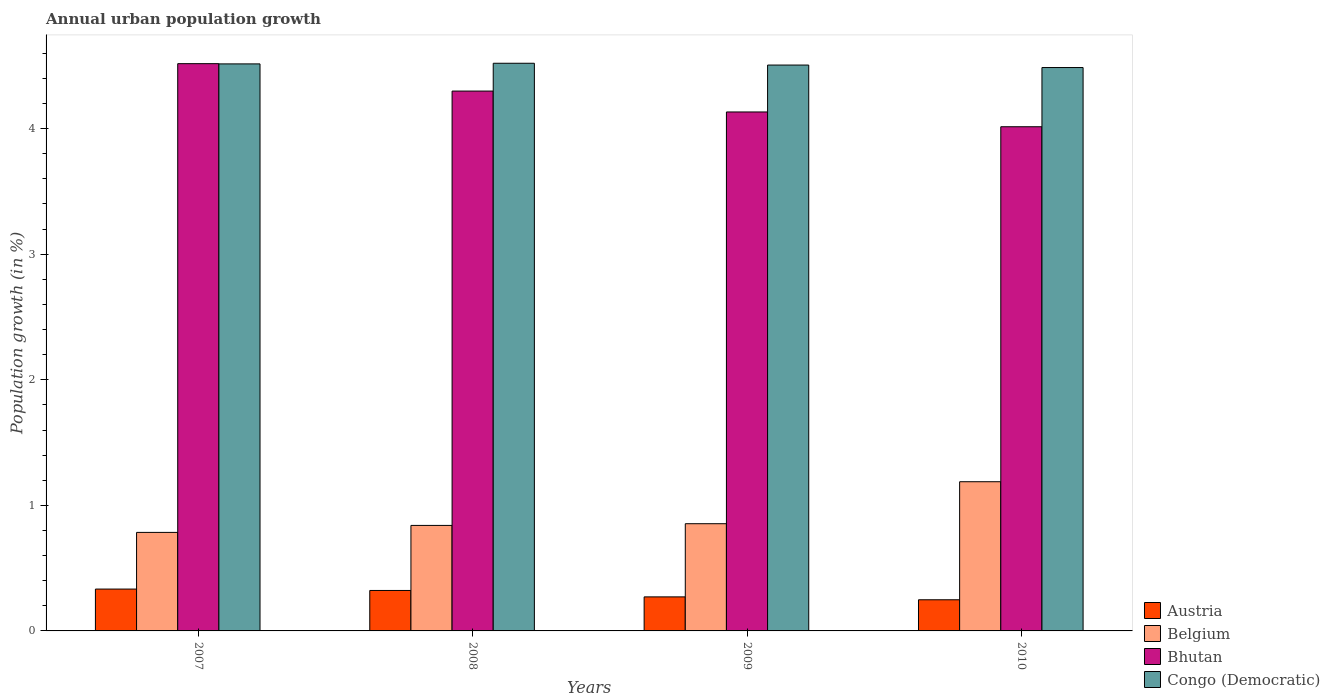How many different coloured bars are there?
Your answer should be compact. 4. How many groups of bars are there?
Keep it short and to the point. 4. What is the label of the 1st group of bars from the left?
Offer a terse response. 2007. What is the percentage of urban population growth in Bhutan in 2007?
Your answer should be compact. 4.52. Across all years, what is the maximum percentage of urban population growth in Belgium?
Ensure brevity in your answer.  1.19. Across all years, what is the minimum percentage of urban population growth in Bhutan?
Make the answer very short. 4.01. In which year was the percentage of urban population growth in Austria minimum?
Keep it short and to the point. 2010. What is the total percentage of urban population growth in Bhutan in the graph?
Ensure brevity in your answer.  16.96. What is the difference between the percentage of urban population growth in Congo (Democratic) in 2007 and that in 2008?
Your answer should be very brief. -0.01. What is the difference between the percentage of urban population growth in Austria in 2008 and the percentage of urban population growth in Belgium in 2007?
Your answer should be compact. -0.46. What is the average percentage of urban population growth in Austria per year?
Offer a very short reply. 0.29. In the year 2008, what is the difference between the percentage of urban population growth in Bhutan and percentage of urban population growth in Austria?
Make the answer very short. 3.98. What is the ratio of the percentage of urban population growth in Congo (Democratic) in 2009 to that in 2010?
Make the answer very short. 1. Is the percentage of urban population growth in Bhutan in 2008 less than that in 2010?
Provide a short and direct response. No. Is the difference between the percentage of urban population growth in Bhutan in 2008 and 2010 greater than the difference between the percentage of urban population growth in Austria in 2008 and 2010?
Provide a short and direct response. Yes. What is the difference between the highest and the second highest percentage of urban population growth in Austria?
Offer a very short reply. 0.01. What is the difference between the highest and the lowest percentage of urban population growth in Austria?
Your answer should be very brief. 0.09. Is it the case that in every year, the sum of the percentage of urban population growth in Bhutan and percentage of urban population growth in Austria is greater than the sum of percentage of urban population growth in Belgium and percentage of urban population growth in Congo (Democratic)?
Your answer should be compact. Yes. What does the 2nd bar from the right in 2009 represents?
Provide a short and direct response. Bhutan. How many bars are there?
Your answer should be very brief. 16. How many years are there in the graph?
Provide a short and direct response. 4. What is the difference between two consecutive major ticks on the Y-axis?
Provide a succinct answer. 1. Where does the legend appear in the graph?
Your answer should be very brief. Bottom right. How are the legend labels stacked?
Keep it short and to the point. Vertical. What is the title of the graph?
Provide a short and direct response. Annual urban population growth. Does "Eritrea" appear as one of the legend labels in the graph?
Provide a short and direct response. No. What is the label or title of the Y-axis?
Offer a terse response. Population growth (in %). What is the Population growth (in %) in Austria in 2007?
Offer a very short reply. 0.33. What is the Population growth (in %) in Belgium in 2007?
Offer a terse response. 0.78. What is the Population growth (in %) in Bhutan in 2007?
Make the answer very short. 4.52. What is the Population growth (in %) of Congo (Democratic) in 2007?
Your answer should be compact. 4.52. What is the Population growth (in %) of Austria in 2008?
Provide a short and direct response. 0.32. What is the Population growth (in %) in Belgium in 2008?
Your response must be concise. 0.84. What is the Population growth (in %) in Bhutan in 2008?
Offer a terse response. 4.3. What is the Population growth (in %) in Congo (Democratic) in 2008?
Offer a very short reply. 4.52. What is the Population growth (in %) in Austria in 2009?
Keep it short and to the point. 0.27. What is the Population growth (in %) in Belgium in 2009?
Give a very brief answer. 0.85. What is the Population growth (in %) of Bhutan in 2009?
Provide a succinct answer. 4.13. What is the Population growth (in %) of Congo (Democratic) in 2009?
Give a very brief answer. 4.51. What is the Population growth (in %) of Austria in 2010?
Provide a succinct answer. 0.25. What is the Population growth (in %) in Belgium in 2010?
Ensure brevity in your answer.  1.19. What is the Population growth (in %) in Bhutan in 2010?
Your response must be concise. 4.01. What is the Population growth (in %) in Congo (Democratic) in 2010?
Offer a very short reply. 4.49. Across all years, what is the maximum Population growth (in %) in Austria?
Ensure brevity in your answer.  0.33. Across all years, what is the maximum Population growth (in %) in Belgium?
Provide a short and direct response. 1.19. Across all years, what is the maximum Population growth (in %) in Bhutan?
Give a very brief answer. 4.52. Across all years, what is the maximum Population growth (in %) of Congo (Democratic)?
Provide a short and direct response. 4.52. Across all years, what is the minimum Population growth (in %) of Austria?
Keep it short and to the point. 0.25. Across all years, what is the minimum Population growth (in %) of Belgium?
Provide a short and direct response. 0.78. Across all years, what is the minimum Population growth (in %) in Bhutan?
Offer a very short reply. 4.01. Across all years, what is the minimum Population growth (in %) of Congo (Democratic)?
Provide a short and direct response. 4.49. What is the total Population growth (in %) of Austria in the graph?
Offer a very short reply. 1.17. What is the total Population growth (in %) of Belgium in the graph?
Keep it short and to the point. 3.67. What is the total Population growth (in %) of Bhutan in the graph?
Offer a very short reply. 16.96. What is the total Population growth (in %) of Congo (Democratic) in the graph?
Provide a short and direct response. 18.03. What is the difference between the Population growth (in %) of Austria in 2007 and that in 2008?
Provide a succinct answer. 0.01. What is the difference between the Population growth (in %) in Belgium in 2007 and that in 2008?
Offer a very short reply. -0.06. What is the difference between the Population growth (in %) in Bhutan in 2007 and that in 2008?
Give a very brief answer. 0.22. What is the difference between the Population growth (in %) of Congo (Democratic) in 2007 and that in 2008?
Ensure brevity in your answer.  -0.01. What is the difference between the Population growth (in %) of Austria in 2007 and that in 2009?
Keep it short and to the point. 0.06. What is the difference between the Population growth (in %) in Belgium in 2007 and that in 2009?
Offer a terse response. -0.07. What is the difference between the Population growth (in %) in Bhutan in 2007 and that in 2009?
Offer a terse response. 0.38. What is the difference between the Population growth (in %) in Congo (Democratic) in 2007 and that in 2009?
Make the answer very short. 0.01. What is the difference between the Population growth (in %) of Austria in 2007 and that in 2010?
Ensure brevity in your answer.  0.09. What is the difference between the Population growth (in %) in Belgium in 2007 and that in 2010?
Your answer should be compact. -0.4. What is the difference between the Population growth (in %) of Bhutan in 2007 and that in 2010?
Your answer should be very brief. 0.5. What is the difference between the Population growth (in %) in Congo (Democratic) in 2007 and that in 2010?
Keep it short and to the point. 0.03. What is the difference between the Population growth (in %) of Austria in 2008 and that in 2009?
Make the answer very short. 0.05. What is the difference between the Population growth (in %) in Belgium in 2008 and that in 2009?
Your response must be concise. -0.01. What is the difference between the Population growth (in %) in Bhutan in 2008 and that in 2009?
Your answer should be very brief. 0.17. What is the difference between the Population growth (in %) in Congo (Democratic) in 2008 and that in 2009?
Ensure brevity in your answer.  0.01. What is the difference between the Population growth (in %) of Austria in 2008 and that in 2010?
Make the answer very short. 0.07. What is the difference between the Population growth (in %) in Belgium in 2008 and that in 2010?
Give a very brief answer. -0.35. What is the difference between the Population growth (in %) in Bhutan in 2008 and that in 2010?
Offer a very short reply. 0.28. What is the difference between the Population growth (in %) in Congo (Democratic) in 2008 and that in 2010?
Offer a very short reply. 0.03. What is the difference between the Population growth (in %) of Austria in 2009 and that in 2010?
Give a very brief answer. 0.02. What is the difference between the Population growth (in %) in Belgium in 2009 and that in 2010?
Your answer should be very brief. -0.33. What is the difference between the Population growth (in %) in Bhutan in 2009 and that in 2010?
Provide a succinct answer. 0.12. What is the difference between the Population growth (in %) in Congo (Democratic) in 2009 and that in 2010?
Provide a short and direct response. 0.02. What is the difference between the Population growth (in %) of Austria in 2007 and the Population growth (in %) of Belgium in 2008?
Offer a very short reply. -0.51. What is the difference between the Population growth (in %) of Austria in 2007 and the Population growth (in %) of Bhutan in 2008?
Give a very brief answer. -3.97. What is the difference between the Population growth (in %) of Austria in 2007 and the Population growth (in %) of Congo (Democratic) in 2008?
Offer a very short reply. -4.19. What is the difference between the Population growth (in %) of Belgium in 2007 and the Population growth (in %) of Bhutan in 2008?
Give a very brief answer. -3.51. What is the difference between the Population growth (in %) in Belgium in 2007 and the Population growth (in %) in Congo (Democratic) in 2008?
Provide a short and direct response. -3.74. What is the difference between the Population growth (in %) in Bhutan in 2007 and the Population growth (in %) in Congo (Democratic) in 2008?
Ensure brevity in your answer.  -0. What is the difference between the Population growth (in %) in Austria in 2007 and the Population growth (in %) in Belgium in 2009?
Your response must be concise. -0.52. What is the difference between the Population growth (in %) in Austria in 2007 and the Population growth (in %) in Bhutan in 2009?
Give a very brief answer. -3.8. What is the difference between the Population growth (in %) in Austria in 2007 and the Population growth (in %) in Congo (Democratic) in 2009?
Give a very brief answer. -4.17. What is the difference between the Population growth (in %) in Belgium in 2007 and the Population growth (in %) in Bhutan in 2009?
Your answer should be very brief. -3.35. What is the difference between the Population growth (in %) of Belgium in 2007 and the Population growth (in %) of Congo (Democratic) in 2009?
Give a very brief answer. -3.72. What is the difference between the Population growth (in %) of Bhutan in 2007 and the Population growth (in %) of Congo (Democratic) in 2009?
Offer a terse response. 0.01. What is the difference between the Population growth (in %) of Austria in 2007 and the Population growth (in %) of Belgium in 2010?
Keep it short and to the point. -0.85. What is the difference between the Population growth (in %) of Austria in 2007 and the Population growth (in %) of Bhutan in 2010?
Offer a very short reply. -3.68. What is the difference between the Population growth (in %) in Austria in 2007 and the Population growth (in %) in Congo (Democratic) in 2010?
Provide a short and direct response. -4.15. What is the difference between the Population growth (in %) of Belgium in 2007 and the Population growth (in %) of Bhutan in 2010?
Offer a very short reply. -3.23. What is the difference between the Population growth (in %) in Belgium in 2007 and the Population growth (in %) in Congo (Democratic) in 2010?
Your response must be concise. -3.7. What is the difference between the Population growth (in %) in Bhutan in 2007 and the Population growth (in %) in Congo (Democratic) in 2010?
Provide a succinct answer. 0.03. What is the difference between the Population growth (in %) of Austria in 2008 and the Population growth (in %) of Belgium in 2009?
Provide a succinct answer. -0.53. What is the difference between the Population growth (in %) in Austria in 2008 and the Population growth (in %) in Bhutan in 2009?
Your response must be concise. -3.81. What is the difference between the Population growth (in %) in Austria in 2008 and the Population growth (in %) in Congo (Democratic) in 2009?
Keep it short and to the point. -4.18. What is the difference between the Population growth (in %) in Belgium in 2008 and the Population growth (in %) in Bhutan in 2009?
Ensure brevity in your answer.  -3.29. What is the difference between the Population growth (in %) of Belgium in 2008 and the Population growth (in %) of Congo (Democratic) in 2009?
Offer a very short reply. -3.67. What is the difference between the Population growth (in %) in Bhutan in 2008 and the Population growth (in %) in Congo (Democratic) in 2009?
Give a very brief answer. -0.21. What is the difference between the Population growth (in %) in Austria in 2008 and the Population growth (in %) in Belgium in 2010?
Provide a short and direct response. -0.87. What is the difference between the Population growth (in %) of Austria in 2008 and the Population growth (in %) of Bhutan in 2010?
Offer a terse response. -3.69. What is the difference between the Population growth (in %) in Austria in 2008 and the Population growth (in %) in Congo (Democratic) in 2010?
Your answer should be compact. -4.16. What is the difference between the Population growth (in %) of Belgium in 2008 and the Population growth (in %) of Bhutan in 2010?
Provide a short and direct response. -3.17. What is the difference between the Population growth (in %) in Belgium in 2008 and the Population growth (in %) in Congo (Democratic) in 2010?
Give a very brief answer. -3.65. What is the difference between the Population growth (in %) in Bhutan in 2008 and the Population growth (in %) in Congo (Democratic) in 2010?
Your answer should be compact. -0.19. What is the difference between the Population growth (in %) of Austria in 2009 and the Population growth (in %) of Belgium in 2010?
Your answer should be compact. -0.92. What is the difference between the Population growth (in %) of Austria in 2009 and the Population growth (in %) of Bhutan in 2010?
Offer a very short reply. -3.74. What is the difference between the Population growth (in %) in Austria in 2009 and the Population growth (in %) in Congo (Democratic) in 2010?
Provide a succinct answer. -4.22. What is the difference between the Population growth (in %) of Belgium in 2009 and the Population growth (in %) of Bhutan in 2010?
Provide a short and direct response. -3.16. What is the difference between the Population growth (in %) in Belgium in 2009 and the Population growth (in %) in Congo (Democratic) in 2010?
Make the answer very short. -3.63. What is the difference between the Population growth (in %) in Bhutan in 2009 and the Population growth (in %) in Congo (Democratic) in 2010?
Give a very brief answer. -0.35. What is the average Population growth (in %) in Austria per year?
Provide a short and direct response. 0.29. What is the average Population growth (in %) of Belgium per year?
Make the answer very short. 0.92. What is the average Population growth (in %) of Bhutan per year?
Keep it short and to the point. 4.24. What is the average Population growth (in %) of Congo (Democratic) per year?
Your answer should be compact. 4.51. In the year 2007, what is the difference between the Population growth (in %) of Austria and Population growth (in %) of Belgium?
Offer a terse response. -0.45. In the year 2007, what is the difference between the Population growth (in %) of Austria and Population growth (in %) of Bhutan?
Your answer should be compact. -4.18. In the year 2007, what is the difference between the Population growth (in %) of Austria and Population growth (in %) of Congo (Democratic)?
Give a very brief answer. -4.18. In the year 2007, what is the difference between the Population growth (in %) in Belgium and Population growth (in %) in Bhutan?
Give a very brief answer. -3.73. In the year 2007, what is the difference between the Population growth (in %) of Belgium and Population growth (in %) of Congo (Democratic)?
Your response must be concise. -3.73. In the year 2007, what is the difference between the Population growth (in %) of Bhutan and Population growth (in %) of Congo (Democratic)?
Provide a short and direct response. 0. In the year 2008, what is the difference between the Population growth (in %) of Austria and Population growth (in %) of Belgium?
Provide a short and direct response. -0.52. In the year 2008, what is the difference between the Population growth (in %) in Austria and Population growth (in %) in Bhutan?
Your answer should be compact. -3.98. In the year 2008, what is the difference between the Population growth (in %) in Austria and Population growth (in %) in Congo (Democratic)?
Provide a succinct answer. -4.2. In the year 2008, what is the difference between the Population growth (in %) of Belgium and Population growth (in %) of Bhutan?
Ensure brevity in your answer.  -3.46. In the year 2008, what is the difference between the Population growth (in %) in Belgium and Population growth (in %) in Congo (Democratic)?
Your answer should be very brief. -3.68. In the year 2008, what is the difference between the Population growth (in %) in Bhutan and Population growth (in %) in Congo (Democratic)?
Your answer should be compact. -0.22. In the year 2009, what is the difference between the Population growth (in %) in Austria and Population growth (in %) in Belgium?
Make the answer very short. -0.58. In the year 2009, what is the difference between the Population growth (in %) of Austria and Population growth (in %) of Bhutan?
Keep it short and to the point. -3.86. In the year 2009, what is the difference between the Population growth (in %) in Austria and Population growth (in %) in Congo (Democratic)?
Ensure brevity in your answer.  -4.24. In the year 2009, what is the difference between the Population growth (in %) of Belgium and Population growth (in %) of Bhutan?
Offer a very short reply. -3.28. In the year 2009, what is the difference between the Population growth (in %) of Belgium and Population growth (in %) of Congo (Democratic)?
Provide a succinct answer. -3.65. In the year 2009, what is the difference between the Population growth (in %) in Bhutan and Population growth (in %) in Congo (Democratic)?
Keep it short and to the point. -0.37. In the year 2010, what is the difference between the Population growth (in %) in Austria and Population growth (in %) in Belgium?
Give a very brief answer. -0.94. In the year 2010, what is the difference between the Population growth (in %) in Austria and Population growth (in %) in Bhutan?
Your answer should be very brief. -3.77. In the year 2010, what is the difference between the Population growth (in %) in Austria and Population growth (in %) in Congo (Democratic)?
Your response must be concise. -4.24. In the year 2010, what is the difference between the Population growth (in %) of Belgium and Population growth (in %) of Bhutan?
Your answer should be compact. -2.83. In the year 2010, what is the difference between the Population growth (in %) of Belgium and Population growth (in %) of Congo (Democratic)?
Give a very brief answer. -3.3. In the year 2010, what is the difference between the Population growth (in %) in Bhutan and Population growth (in %) in Congo (Democratic)?
Make the answer very short. -0.47. What is the ratio of the Population growth (in %) in Austria in 2007 to that in 2008?
Your answer should be compact. 1.03. What is the ratio of the Population growth (in %) of Belgium in 2007 to that in 2008?
Your response must be concise. 0.93. What is the ratio of the Population growth (in %) in Bhutan in 2007 to that in 2008?
Provide a short and direct response. 1.05. What is the ratio of the Population growth (in %) in Austria in 2007 to that in 2009?
Your answer should be very brief. 1.23. What is the ratio of the Population growth (in %) of Belgium in 2007 to that in 2009?
Your response must be concise. 0.92. What is the ratio of the Population growth (in %) of Bhutan in 2007 to that in 2009?
Offer a very short reply. 1.09. What is the ratio of the Population growth (in %) in Austria in 2007 to that in 2010?
Your answer should be very brief. 1.34. What is the ratio of the Population growth (in %) in Belgium in 2007 to that in 2010?
Your response must be concise. 0.66. What is the ratio of the Population growth (in %) in Bhutan in 2007 to that in 2010?
Your answer should be very brief. 1.13. What is the ratio of the Population growth (in %) in Congo (Democratic) in 2007 to that in 2010?
Your answer should be very brief. 1.01. What is the ratio of the Population growth (in %) in Austria in 2008 to that in 2009?
Your response must be concise. 1.19. What is the ratio of the Population growth (in %) in Belgium in 2008 to that in 2009?
Ensure brevity in your answer.  0.98. What is the ratio of the Population growth (in %) in Bhutan in 2008 to that in 2009?
Offer a terse response. 1.04. What is the ratio of the Population growth (in %) of Congo (Democratic) in 2008 to that in 2009?
Your answer should be very brief. 1. What is the ratio of the Population growth (in %) in Austria in 2008 to that in 2010?
Your answer should be very brief. 1.3. What is the ratio of the Population growth (in %) of Belgium in 2008 to that in 2010?
Provide a succinct answer. 0.71. What is the ratio of the Population growth (in %) in Bhutan in 2008 to that in 2010?
Provide a short and direct response. 1.07. What is the ratio of the Population growth (in %) in Congo (Democratic) in 2008 to that in 2010?
Ensure brevity in your answer.  1.01. What is the ratio of the Population growth (in %) of Austria in 2009 to that in 2010?
Provide a short and direct response. 1.09. What is the ratio of the Population growth (in %) of Belgium in 2009 to that in 2010?
Ensure brevity in your answer.  0.72. What is the ratio of the Population growth (in %) of Bhutan in 2009 to that in 2010?
Your answer should be compact. 1.03. What is the ratio of the Population growth (in %) in Congo (Democratic) in 2009 to that in 2010?
Your answer should be compact. 1. What is the difference between the highest and the second highest Population growth (in %) in Austria?
Make the answer very short. 0.01. What is the difference between the highest and the second highest Population growth (in %) in Belgium?
Provide a succinct answer. 0.33. What is the difference between the highest and the second highest Population growth (in %) in Bhutan?
Your answer should be very brief. 0.22. What is the difference between the highest and the second highest Population growth (in %) of Congo (Democratic)?
Provide a short and direct response. 0.01. What is the difference between the highest and the lowest Population growth (in %) of Austria?
Make the answer very short. 0.09. What is the difference between the highest and the lowest Population growth (in %) of Belgium?
Offer a very short reply. 0.4. What is the difference between the highest and the lowest Population growth (in %) of Bhutan?
Give a very brief answer. 0.5. What is the difference between the highest and the lowest Population growth (in %) of Congo (Democratic)?
Your response must be concise. 0.03. 